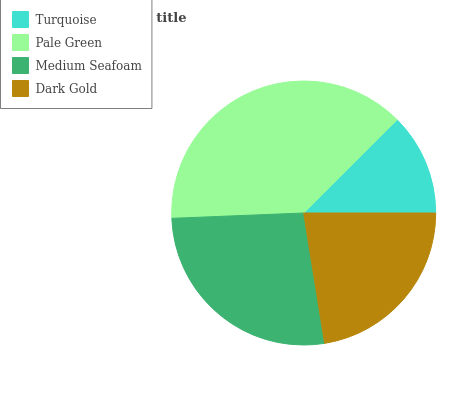Is Turquoise the minimum?
Answer yes or no. Yes. Is Pale Green the maximum?
Answer yes or no. Yes. Is Medium Seafoam the minimum?
Answer yes or no. No. Is Medium Seafoam the maximum?
Answer yes or no. No. Is Pale Green greater than Medium Seafoam?
Answer yes or no. Yes. Is Medium Seafoam less than Pale Green?
Answer yes or no. Yes. Is Medium Seafoam greater than Pale Green?
Answer yes or no. No. Is Pale Green less than Medium Seafoam?
Answer yes or no. No. Is Medium Seafoam the high median?
Answer yes or no. Yes. Is Dark Gold the low median?
Answer yes or no. Yes. Is Turquoise the high median?
Answer yes or no. No. Is Medium Seafoam the low median?
Answer yes or no. No. 